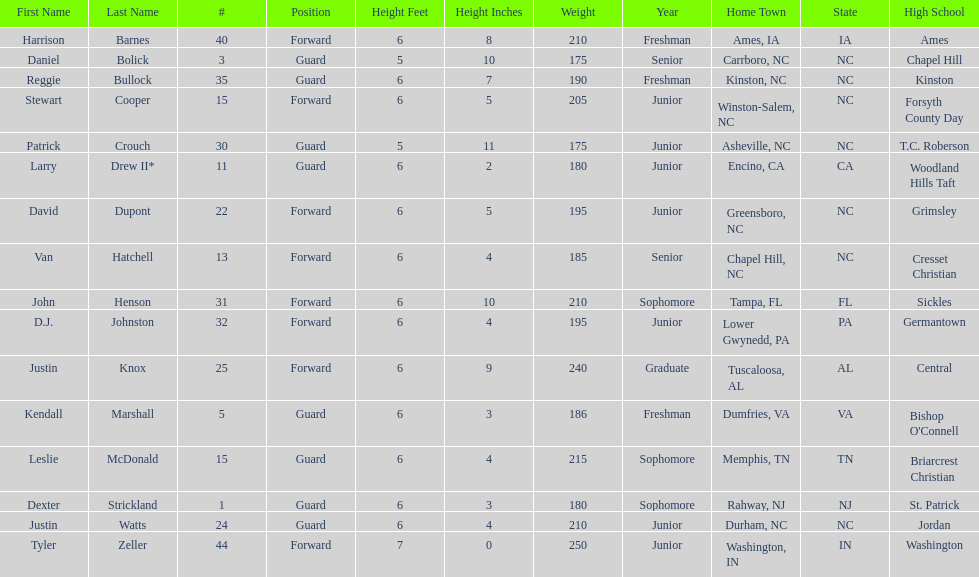What was the number of freshmen on the team? 3. 